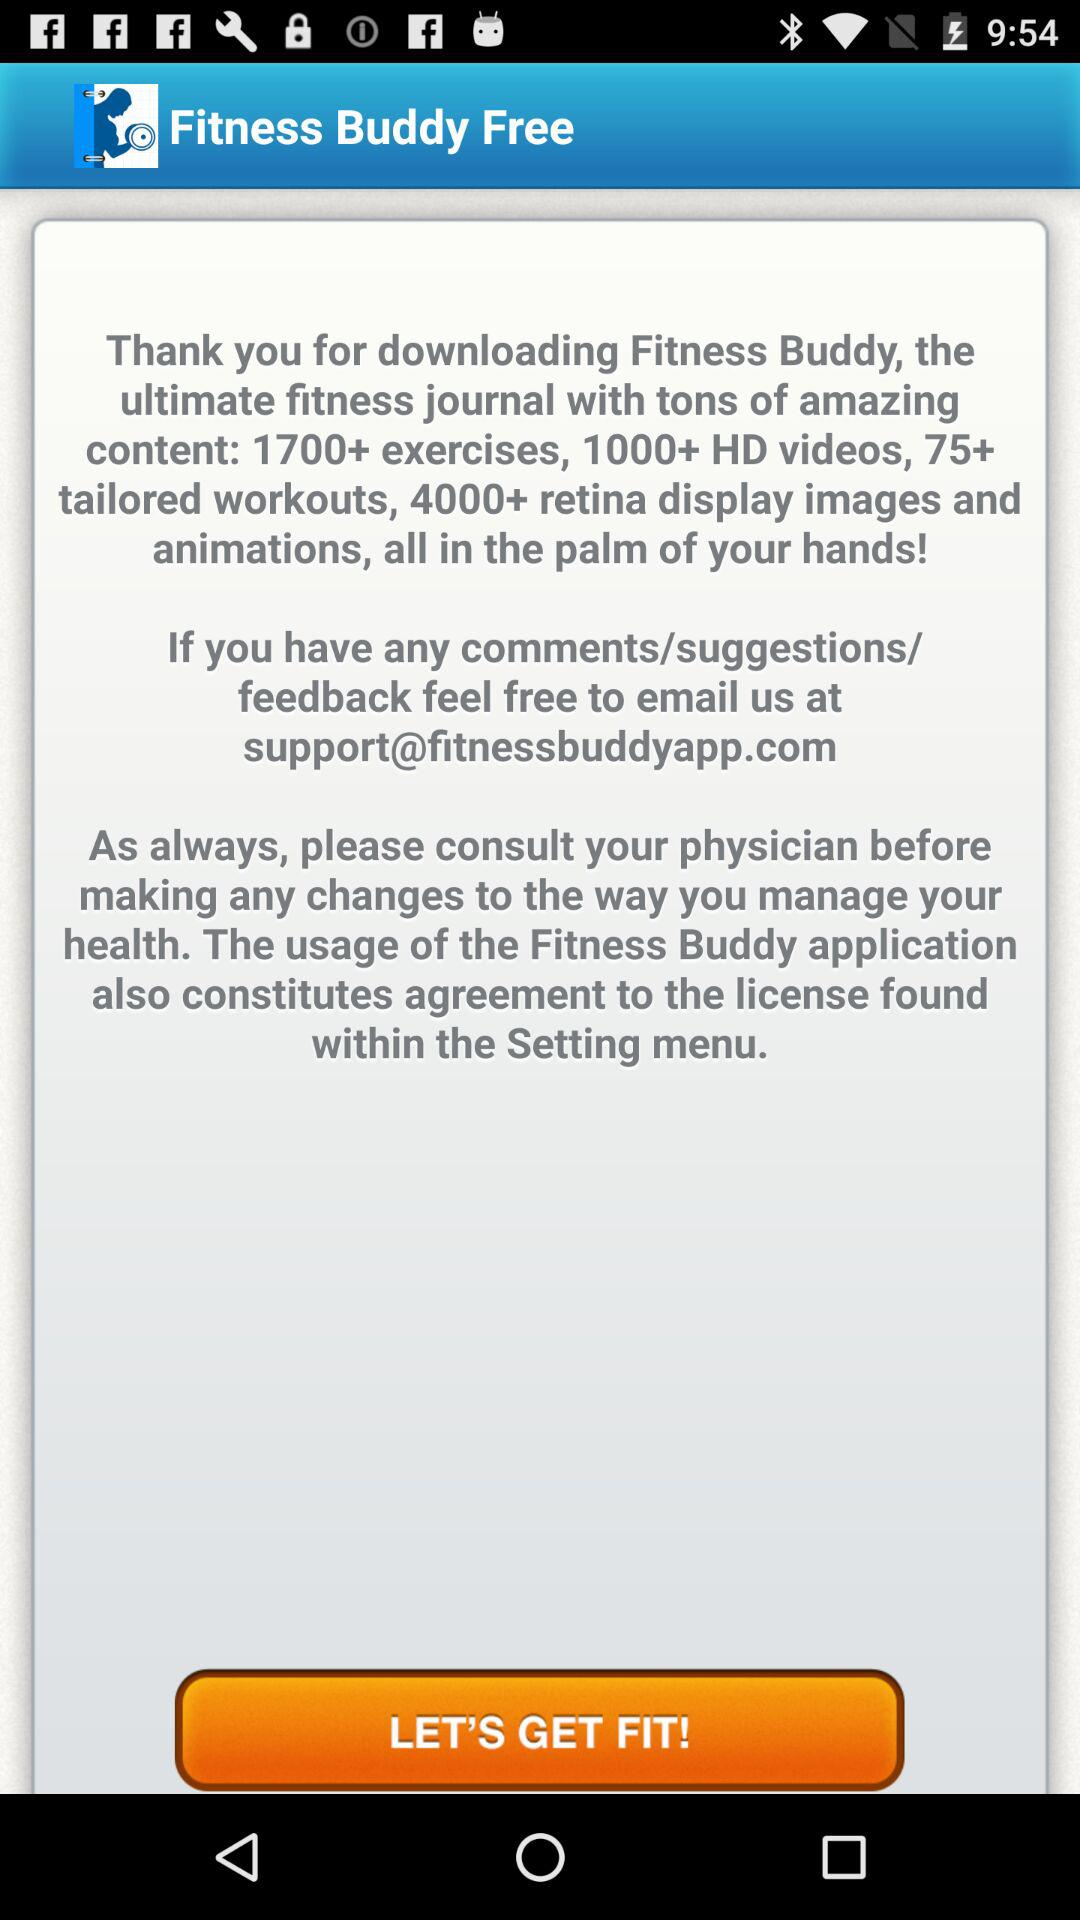What is the application name? The application name is "Fitness Buddy Free". 